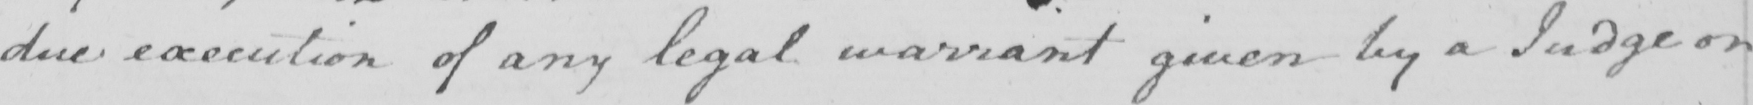Can you read and transcribe this handwriting? due execution of any legal warrant given by a judge or 